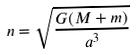<formula> <loc_0><loc_0><loc_500><loc_500>n = \sqrt { \frac { G ( M + m ) } { a ^ { 3 } } }</formula> 